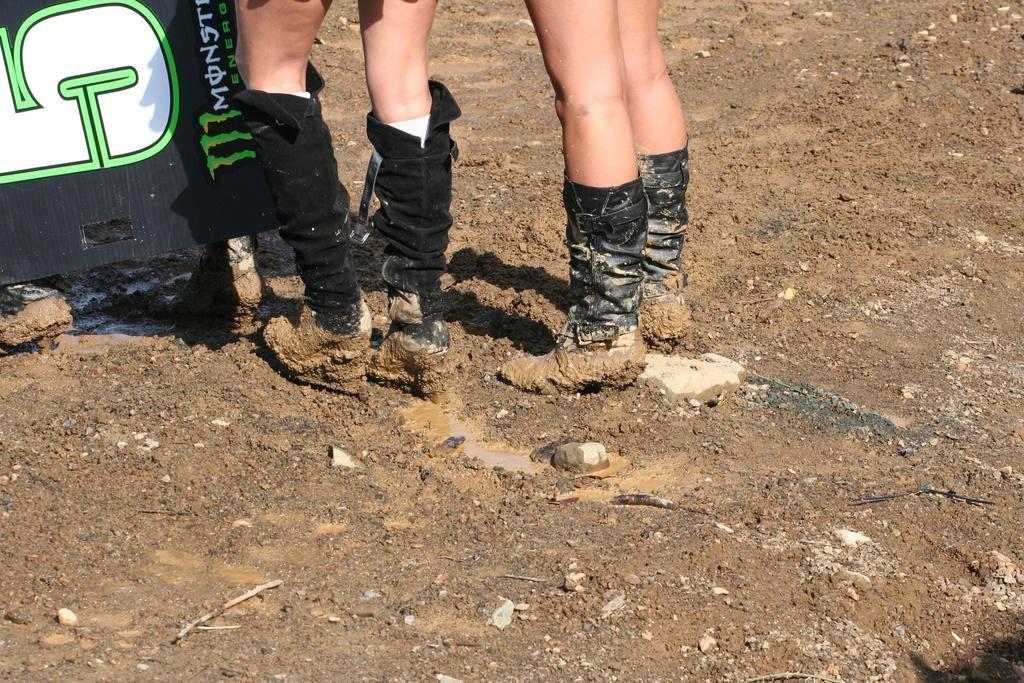How would you summarize this image in a sentence or two? In this image we can see the people legs. We can also see a text board, water, stones and also the soil. 